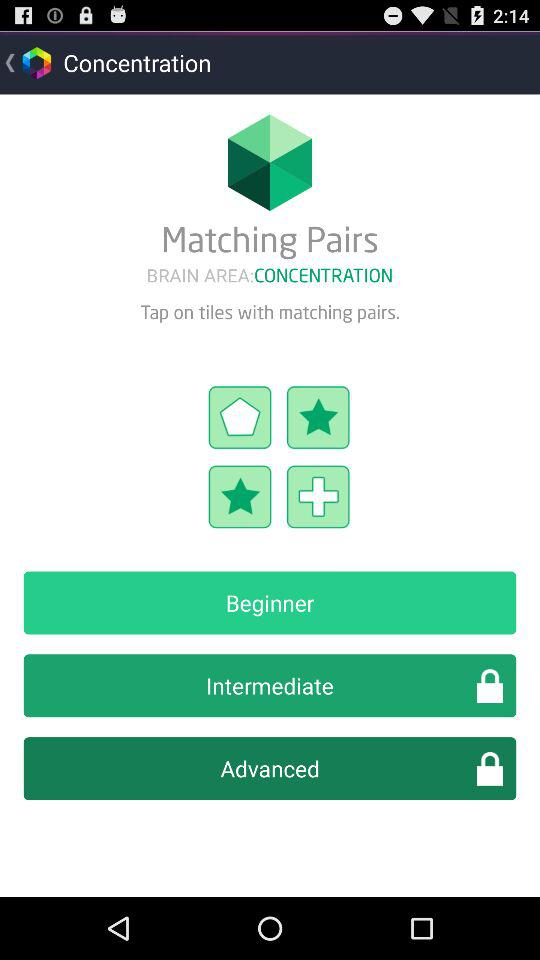Which level is unlocked? The unlocked level is "Beginner". 